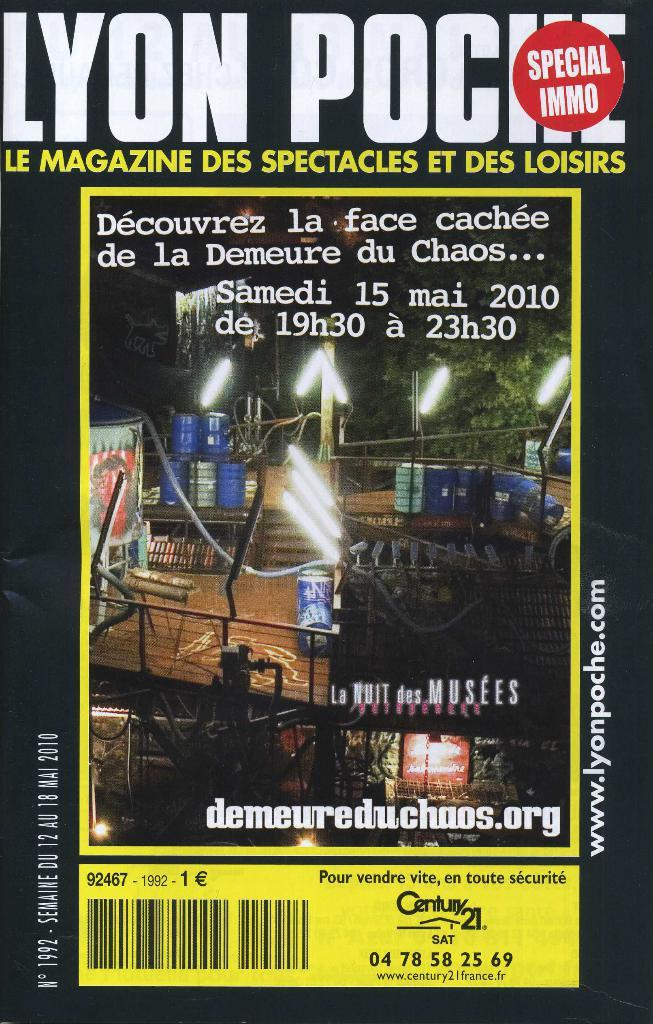Provide a one-sentence caption for the provided image. A magazine cover has a Century 21 ad on the bottom. 